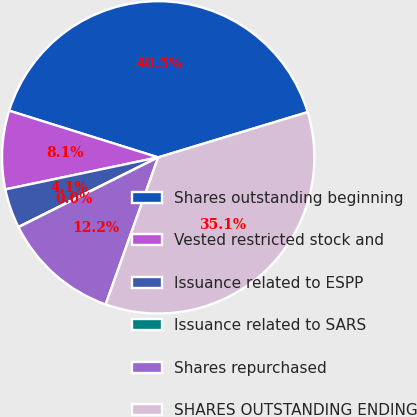Convert chart. <chart><loc_0><loc_0><loc_500><loc_500><pie_chart><fcel>Shares outstanding beginning<fcel>Vested restricted stock and<fcel>Issuance related to ESPP<fcel>Issuance related to SARS<fcel>Shares repurchased<fcel>SHARES OUTSTANDING ENDING<nl><fcel>40.49%<fcel>8.12%<fcel>4.07%<fcel>0.02%<fcel>12.16%<fcel>35.14%<nl></chart> 